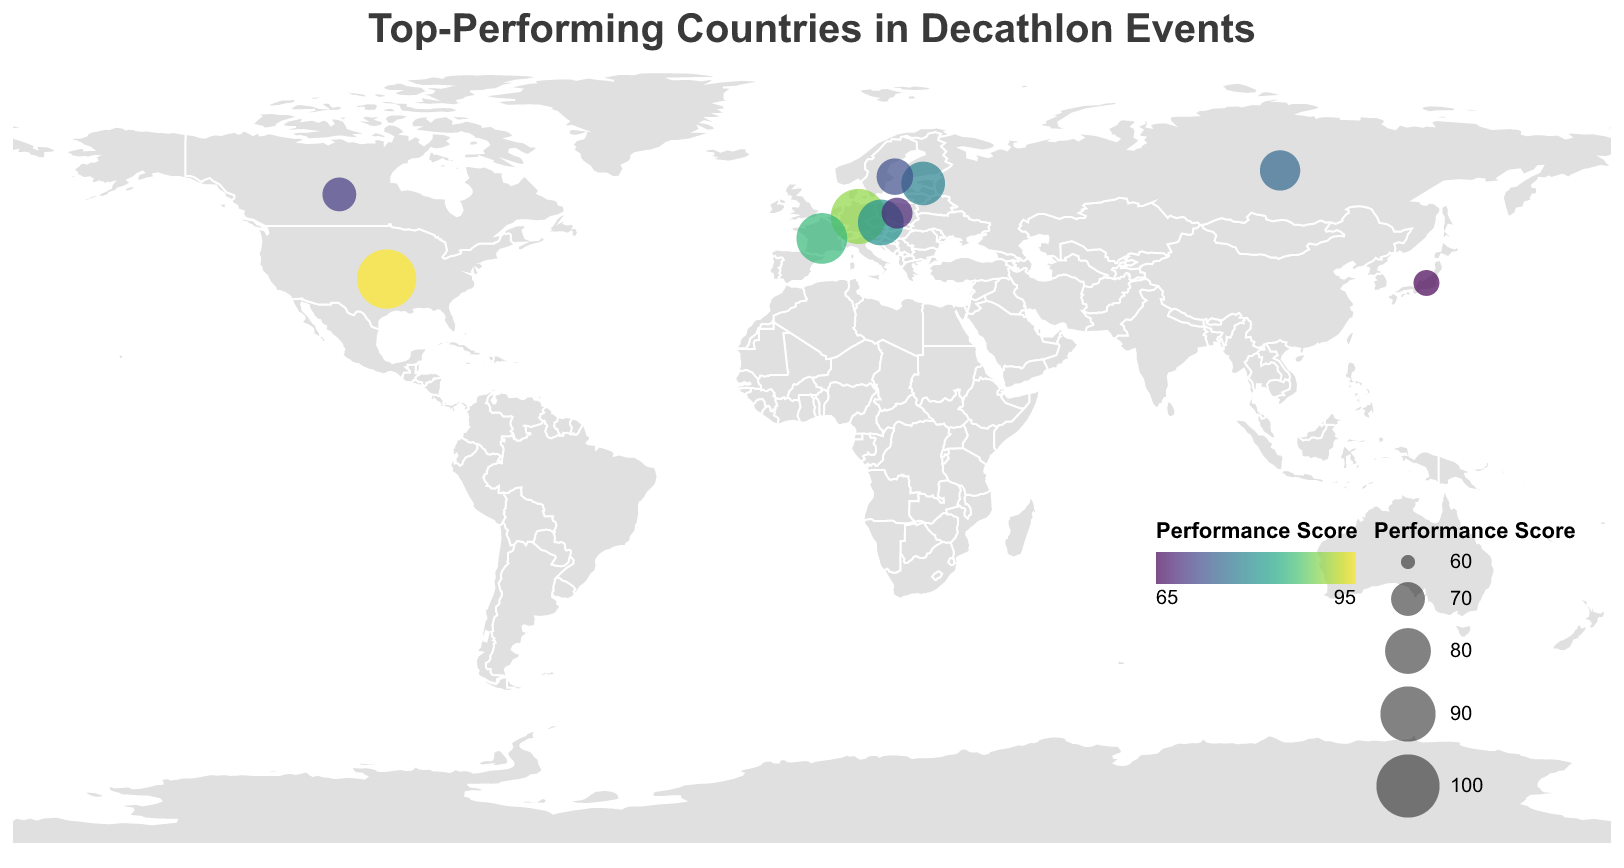Which country has the highest performance score? The country with the largest circle and the highest color intensity in the heatmap has the highest performance score. The United States has the highest performance score of 95.
Answer: United States What is the title of the plot? The title appears prominently at the top center of the figure.
Answer: Top-Performing Countries in Decathlon Events Which country is represented by the smallest circle? The smallest circle corresponds to the country with the lowest performance score, which is in Japan with a score of 65.
Answer: Japan How many countries are represented in the plot? Each country is represented by one circle on the heatmap. Counting the circles shows there are 10 countries represented.
Answer: 10 What is the range of performance scores depicted in the legend? The legend at the bottom-right of the map shows the range of performance scores. The scale ranges from 60 to 100.
Answer: 60 to 100 Compare the performance scores of Estonia and Poland. Which one is higher and by how much? Estonia has a performance score of 78 while Poland has a score of 68. Subtracting 68 from 78 gives 10. Therefore, Estonia's performance score is higher by 10.
Answer: Estonia by 10 Which countries have performance scores above 80? By inspecting the circles and their corresponding performance scores, the countries above 80 are the United States (95), Germany (90), France (85), and Czech Republic (80).
Answer: United States, Germany, France, Czech Republic What is the total sum of the performance scores of all countries? Adding all the individual performance scores: 95 (United States) + 90 (Germany) + 85 (France) + 80 (Czech Republic) + 78 (Estonia) + 75 (Russia) + 72 (Sweden) + 70 (Canada) + 68 (Poland) + 65 (Japan) = 778.
Answer: 778 Which country is located at approximately Latitude 60 and Longitude 18? Referring to the latitude and longitude values, the country located at approximately Latitude 60 and Longitude 18 is Sweden.
Answer: Sweden What color scheme is used to represent the performance scores? The color scheme used in the visual figure is mentioned in the explanation, "viridis." The colors vary across the performance scores, with high scores being represented by one end of the viridis spectrum and lower scores by the other.
Answer: Viridis 